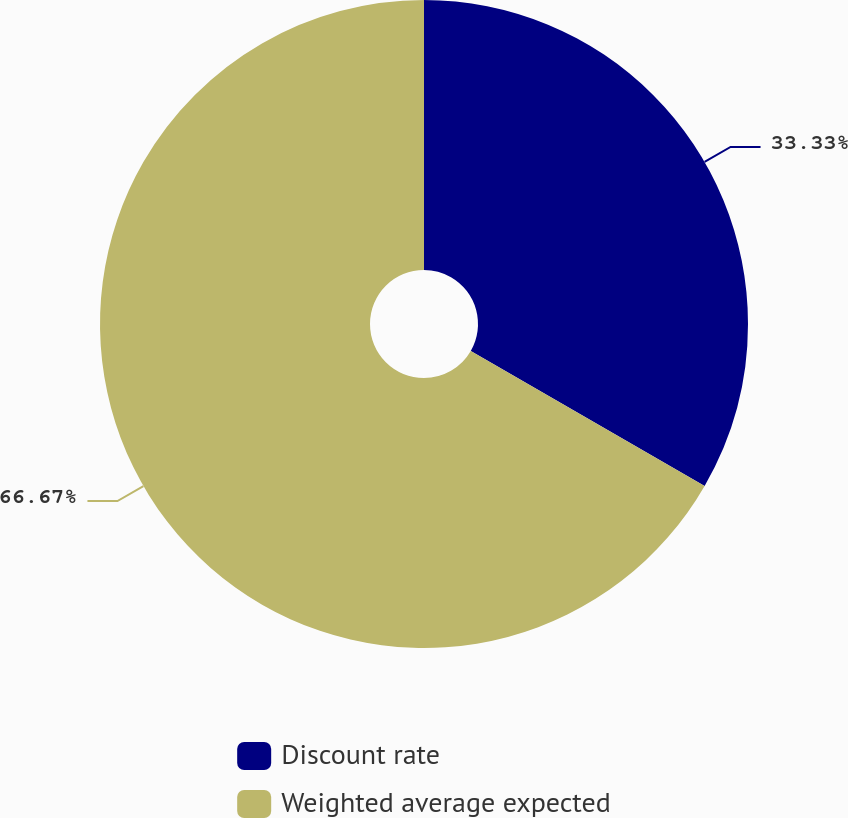Convert chart to OTSL. <chart><loc_0><loc_0><loc_500><loc_500><pie_chart><fcel>Discount rate<fcel>Weighted average expected<nl><fcel>33.33%<fcel>66.67%<nl></chart> 